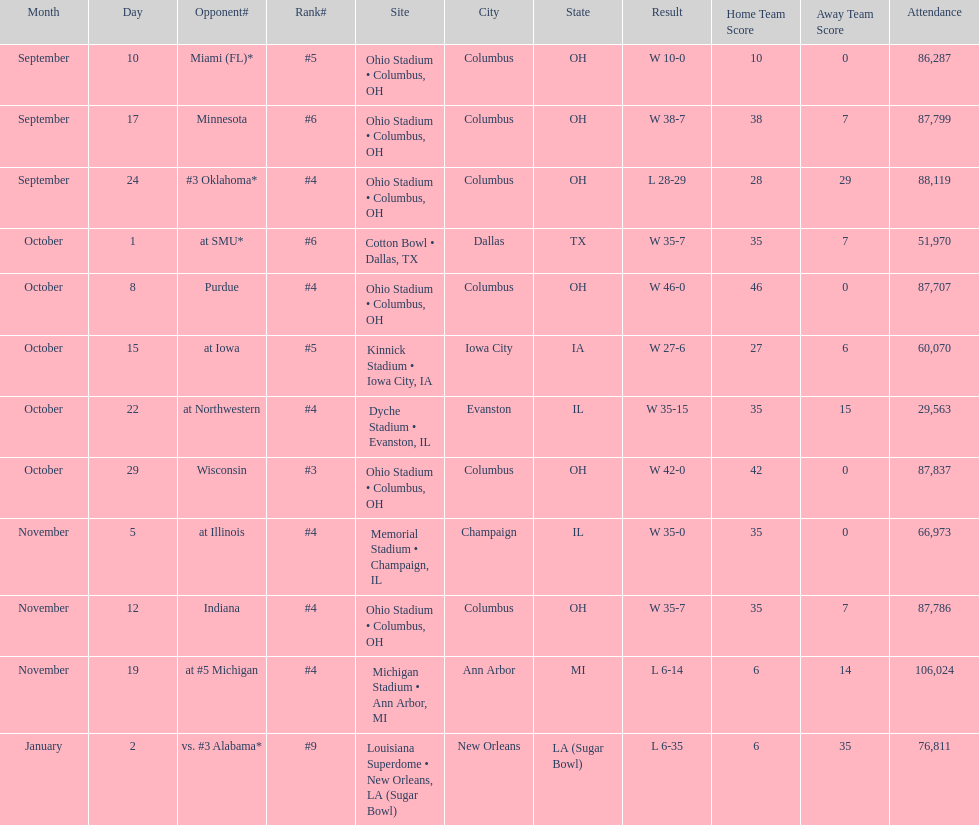How many games did this team win during this season? 9. 